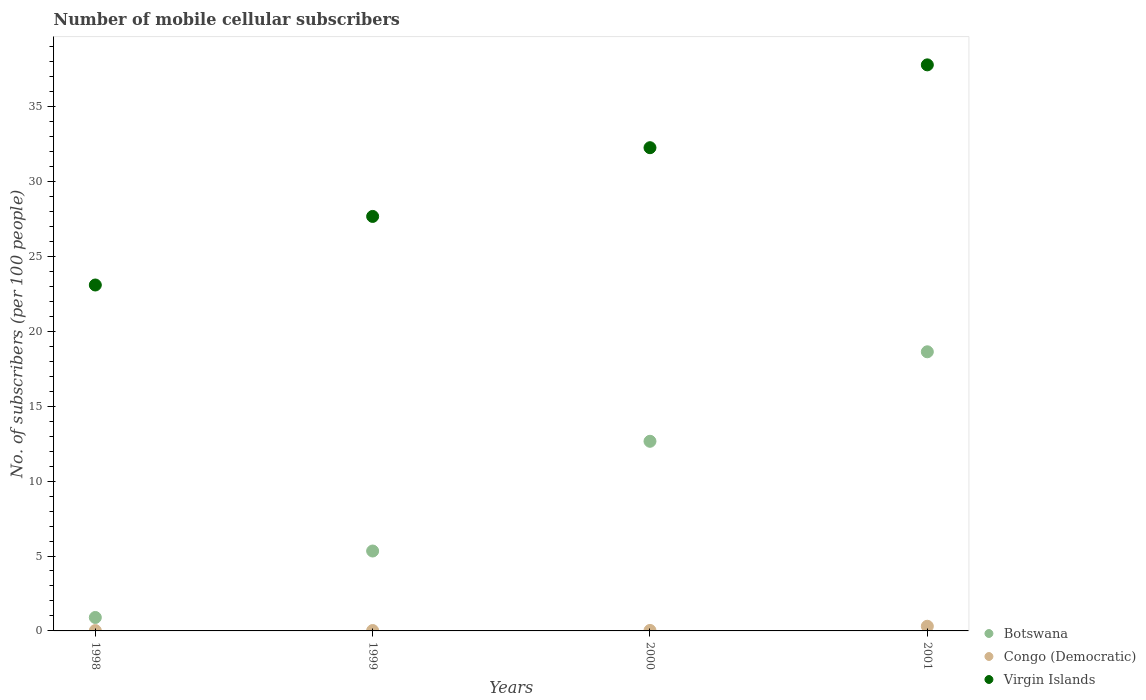Is the number of dotlines equal to the number of legend labels?
Your response must be concise. Yes. What is the number of mobile cellular subscribers in Virgin Islands in 2000?
Your answer should be compact. 32.25. Across all years, what is the maximum number of mobile cellular subscribers in Botswana?
Keep it short and to the point. 18.63. Across all years, what is the minimum number of mobile cellular subscribers in Botswana?
Your answer should be very brief. 0.9. In which year was the number of mobile cellular subscribers in Botswana maximum?
Give a very brief answer. 2001. What is the total number of mobile cellular subscribers in Virgin Islands in the graph?
Offer a very short reply. 120.8. What is the difference between the number of mobile cellular subscribers in Botswana in 1999 and that in 2001?
Keep it short and to the point. -13.3. What is the difference between the number of mobile cellular subscribers in Virgin Islands in 1998 and the number of mobile cellular subscribers in Congo (Democratic) in 1999?
Offer a terse response. 23.06. What is the average number of mobile cellular subscribers in Virgin Islands per year?
Your answer should be very brief. 30.2. In the year 2001, what is the difference between the number of mobile cellular subscribers in Virgin Islands and number of mobile cellular subscribers in Botswana?
Offer a terse response. 19.15. What is the ratio of the number of mobile cellular subscribers in Congo (Democratic) in 1999 to that in 2001?
Offer a very short reply. 0.08. Is the number of mobile cellular subscribers in Virgin Islands in 1999 less than that in 2000?
Your response must be concise. Yes. What is the difference between the highest and the second highest number of mobile cellular subscribers in Virgin Islands?
Your response must be concise. 5.53. What is the difference between the highest and the lowest number of mobile cellular subscribers in Virgin Islands?
Ensure brevity in your answer.  14.69. In how many years, is the number of mobile cellular subscribers in Congo (Democratic) greater than the average number of mobile cellular subscribers in Congo (Democratic) taken over all years?
Ensure brevity in your answer.  1. Is the sum of the number of mobile cellular subscribers in Botswana in 1998 and 2000 greater than the maximum number of mobile cellular subscribers in Congo (Democratic) across all years?
Ensure brevity in your answer.  Yes. Does the number of mobile cellular subscribers in Congo (Democratic) monotonically increase over the years?
Offer a terse response. Yes. Is the number of mobile cellular subscribers in Virgin Islands strictly greater than the number of mobile cellular subscribers in Congo (Democratic) over the years?
Offer a terse response. Yes. Is the number of mobile cellular subscribers in Botswana strictly less than the number of mobile cellular subscribers in Congo (Democratic) over the years?
Ensure brevity in your answer.  No. How many dotlines are there?
Your answer should be very brief. 3. Are the values on the major ticks of Y-axis written in scientific E-notation?
Your answer should be very brief. No. What is the title of the graph?
Offer a terse response. Number of mobile cellular subscribers. What is the label or title of the Y-axis?
Your response must be concise. No. of subscribers (per 100 people). What is the No. of subscribers (per 100 people) in Botswana in 1998?
Your response must be concise. 0.9. What is the No. of subscribers (per 100 people) of Congo (Democratic) in 1998?
Give a very brief answer. 0.02. What is the No. of subscribers (per 100 people) in Virgin Islands in 1998?
Offer a very short reply. 23.09. What is the No. of subscribers (per 100 people) of Botswana in 1999?
Ensure brevity in your answer.  5.33. What is the No. of subscribers (per 100 people) in Congo (Democratic) in 1999?
Provide a short and direct response. 0.03. What is the No. of subscribers (per 100 people) in Virgin Islands in 1999?
Give a very brief answer. 27.67. What is the No. of subscribers (per 100 people) in Botswana in 2000?
Give a very brief answer. 12.66. What is the No. of subscribers (per 100 people) of Congo (Democratic) in 2000?
Your answer should be very brief. 0.03. What is the No. of subscribers (per 100 people) of Virgin Islands in 2000?
Your answer should be compact. 32.25. What is the No. of subscribers (per 100 people) of Botswana in 2001?
Offer a terse response. 18.63. What is the No. of subscribers (per 100 people) of Congo (Democratic) in 2001?
Make the answer very short. 0.31. What is the No. of subscribers (per 100 people) of Virgin Islands in 2001?
Offer a terse response. 37.78. Across all years, what is the maximum No. of subscribers (per 100 people) of Botswana?
Provide a short and direct response. 18.63. Across all years, what is the maximum No. of subscribers (per 100 people) of Congo (Democratic)?
Provide a succinct answer. 0.31. Across all years, what is the maximum No. of subscribers (per 100 people) in Virgin Islands?
Your answer should be very brief. 37.78. Across all years, what is the minimum No. of subscribers (per 100 people) of Botswana?
Your response must be concise. 0.9. Across all years, what is the minimum No. of subscribers (per 100 people) of Congo (Democratic)?
Provide a short and direct response. 0.02. Across all years, what is the minimum No. of subscribers (per 100 people) in Virgin Islands?
Your answer should be very brief. 23.09. What is the total No. of subscribers (per 100 people) of Botswana in the graph?
Your answer should be compact. 37.52. What is the total No. of subscribers (per 100 people) of Congo (Democratic) in the graph?
Your answer should be very brief. 0.39. What is the total No. of subscribers (per 100 people) in Virgin Islands in the graph?
Provide a short and direct response. 120.8. What is the difference between the No. of subscribers (per 100 people) of Botswana in 1998 and that in 1999?
Your response must be concise. -4.44. What is the difference between the No. of subscribers (per 100 people) of Congo (Democratic) in 1998 and that in 1999?
Provide a short and direct response. -0. What is the difference between the No. of subscribers (per 100 people) in Virgin Islands in 1998 and that in 1999?
Ensure brevity in your answer.  -4.58. What is the difference between the No. of subscribers (per 100 people) in Botswana in 1998 and that in 2000?
Your answer should be compact. -11.76. What is the difference between the No. of subscribers (per 100 people) in Congo (Democratic) in 1998 and that in 2000?
Give a very brief answer. -0.01. What is the difference between the No. of subscribers (per 100 people) in Virgin Islands in 1998 and that in 2000?
Make the answer very short. -9.16. What is the difference between the No. of subscribers (per 100 people) in Botswana in 1998 and that in 2001?
Give a very brief answer. -17.73. What is the difference between the No. of subscribers (per 100 people) in Congo (Democratic) in 1998 and that in 2001?
Offer a very short reply. -0.29. What is the difference between the No. of subscribers (per 100 people) of Virgin Islands in 1998 and that in 2001?
Your response must be concise. -14.69. What is the difference between the No. of subscribers (per 100 people) in Botswana in 1999 and that in 2000?
Your answer should be very brief. -7.32. What is the difference between the No. of subscribers (per 100 people) in Congo (Democratic) in 1999 and that in 2000?
Keep it short and to the point. -0.01. What is the difference between the No. of subscribers (per 100 people) in Virgin Islands in 1999 and that in 2000?
Provide a succinct answer. -4.59. What is the difference between the No. of subscribers (per 100 people) in Botswana in 1999 and that in 2001?
Provide a short and direct response. -13.3. What is the difference between the No. of subscribers (per 100 people) of Congo (Democratic) in 1999 and that in 2001?
Provide a short and direct response. -0.29. What is the difference between the No. of subscribers (per 100 people) in Virgin Islands in 1999 and that in 2001?
Make the answer very short. -10.12. What is the difference between the No. of subscribers (per 100 people) of Botswana in 2000 and that in 2001?
Keep it short and to the point. -5.97. What is the difference between the No. of subscribers (per 100 people) of Congo (Democratic) in 2000 and that in 2001?
Your answer should be compact. -0.28. What is the difference between the No. of subscribers (per 100 people) of Virgin Islands in 2000 and that in 2001?
Ensure brevity in your answer.  -5.53. What is the difference between the No. of subscribers (per 100 people) in Botswana in 1998 and the No. of subscribers (per 100 people) in Congo (Democratic) in 1999?
Offer a very short reply. 0.87. What is the difference between the No. of subscribers (per 100 people) in Botswana in 1998 and the No. of subscribers (per 100 people) in Virgin Islands in 1999?
Ensure brevity in your answer.  -26.77. What is the difference between the No. of subscribers (per 100 people) of Congo (Democratic) in 1998 and the No. of subscribers (per 100 people) of Virgin Islands in 1999?
Your answer should be very brief. -27.65. What is the difference between the No. of subscribers (per 100 people) of Botswana in 1998 and the No. of subscribers (per 100 people) of Congo (Democratic) in 2000?
Provide a succinct answer. 0.87. What is the difference between the No. of subscribers (per 100 people) of Botswana in 1998 and the No. of subscribers (per 100 people) of Virgin Islands in 2000?
Make the answer very short. -31.36. What is the difference between the No. of subscribers (per 100 people) of Congo (Democratic) in 1998 and the No. of subscribers (per 100 people) of Virgin Islands in 2000?
Your response must be concise. -32.23. What is the difference between the No. of subscribers (per 100 people) in Botswana in 1998 and the No. of subscribers (per 100 people) in Congo (Democratic) in 2001?
Your answer should be very brief. 0.59. What is the difference between the No. of subscribers (per 100 people) of Botswana in 1998 and the No. of subscribers (per 100 people) of Virgin Islands in 2001?
Ensure brevity in your answer.  -36.89. What is the difference between the No. of subscribers (per 100 people) of Congo (Democratic) in 1998 and the No. of subscribers (per 100 people) of Virgin Islands in 2001?
Offer a very short reply. -37.76. What is the difference between the No. of subscribers (per 100 people) of Botswana in 1999 and the No. of subscribers (per 100 people) of Congo (Democratic) in 2000?
Make the answer very short. 5.3. What is the difference between the No. of subscribers (per 100 people) in Botswana in 1999 and the No. of subscribers (per 100 people) in Virgin Islands in 2000?
Provide a short and direct response. -26.92. What is the difference between the No. of subscribers (per 100 people) in Congo (Democratic) in 1999 and the No. of subscribers (per 100 people) in Virgin Islands in 2000?
Make the answer very short. -32.23. What is the difference between the No. of subscribers (per 100 people) of Botswana in 1999 and the No. of subscribers (per 100 people) of Congo (Democratic) in 2001?
Offer a terse response. 5.02. What is the difference between the No. of subscribers (per 100 people) in Botswana in 1999 and the No. of subscribers (per 100 people) in Virgin Islands in 2001?
Offer a very short reply. -32.45. What is the difference between the No. of subscribers (per 100 people) of Congo (Democratic) in 1999 and the No. of subscribers (per 100 people) of Virgin Islands in 2001?
Ensure brevity in your answer.  -37.76. What is the difference between the No. of subscribers (per 100 people) in Botswana in 2000 and the No. of subscribers (per 100 people) in Congo (Democratic) in 2001?
Offer a very short reply. 12.35. What is the difference between the No. of subscribers (per 100 people) in Botswana in 2000 and the No. of subscribers (per 100 people) in Virgin Islands in 2001?
Your response must be concise. -25.13. What is the difference between the No. of subscribers (per 100 people) in Congo (Democratic) in 2000 and the No. of subscribers (per 100 people) in Virgin Islands in 2001?
Offer a very short reply. -37.75. What is the average No. of subscribers (per 100 people) in Botswana per year?
Make the answer very short. 9.38. What is the average No. of subscribers (per 100 people) of Congo (Democratic) per year?
Make the answer very short. 0.1. What is the average No. of subscribers (per 100 people) of Virgin Islands per year?
Offer a very short reply. 30.2. In the year 1998, what is the difference between the No. of subscribers (per 100 people) of Botswana and No. of subscribers (per 100 people) of Congo (Democratic)?
Ensure brevity in your answer.  0.88. In the year 1998, what is the difference between the No. of subscribers (per 100 people) of Botswana and No. of subscribers (per 100 people) of Virgin Islands?
Provide a succinct answer. -22.19. In the year 1998, what is the difference between the No. of subscribers (per 100 people) in Congo (Democratic) and No. of subscribers (per 100 people) in Virgin Islands?
Provide a succinct answer. -23.07. In the year 1999, what is the difference between the No. of subscribers (per 100 people) in Botswana and No. of subscribers (per 100 people) in Congo (Democratic)?
Offer a very short reply. 5.31. In the year 1999, what is the difference between the No. of subscribers (per 100 people) in Botswana and No. of subscribers (per 100 people) in Virgin Islands?
Make the answer very short. -22.33. In the year 1999, what is the difference between the No. of subscribers (per 100 people) of Congo (Democratic) and No. of subscribers (per 100 people) of Virgin Islands?
Offer a very short reply. -27.64. In the year 2000, what is the difference between the No. of subscribers (per 100 people) of Botswana and No. of subscribers (per 100 people) of Congo (Democratic)?
Your response must be concise. 12.63. In the year 2000, what is the difference between the No. of subscribers (per 100 people) in Botswana and No. of subscribers (per 100 people) in Virgin Islands?
Your answer should be very brief. -19.6. In the year 2000, what is the difference between the No. of subscribers (per 100 people) of Congo (Democratic) and No. of subscribers (per 100 people) of Virgin Islands?
Give a very brief answer. -32.22. In the year 2001, what is the difference between the No. of subscribers (per 100 people) in Botswana and No. of subscribers (per 100 people) in Congo (Democratic)?
Keep it short and to the point. 18.32. In the year 2001, what is the difference between the No. of subscribers (per 100 people) of Botswana and No. of subscribers (per 100 people) of Virgin Islands?
Your response must be concise. -19.15. In the year 2001, what is the difference between the No. of subscribers (per 100 people) of Congo (Democratic) and No. of subscribers (per 100 people) of Virgin Islands?
Ensure brevity in your answer.  -37.47. What is the ratio of the No. of subscribers (per 100 people) of Botswana in 1998 to that in 1999?
Offer a very short reply. 0.17. What is the ratio of the No. of subscribers (per 100 people) of Congo (Democratic) in 1998 to that in 1999?
Offer a terse response. 0.85. What is the ratio of the No. of subscribers (per 100 people) in Virgin Islands in 1998 to that in 1999?
Provide a short and direct response. 0.83. What is the ratio of the No. of subscribers (per 100 people) of Botswana in 1998 to that in 2000?
Make the answer very short. 0.07. What is the ratio of the No. of subscribers (per 100 people) in Congo (Democratic) in 1998 to that in 2000?
Keep it short and to the point. 0.7. What is the ratio of the No. of subscribers (per 100 people) of Virgin Islands in 1998 to that in 2000?
Make the answer very short. 0.72. What is the ratio of the No. of subscribers (per 100 people) of Botswana in 1998 to that in 2001?
Ensure brevity in your answer.  0.05. What is the ratio of the No. of subscribers (per 100 people) of Congo (Democratic) in 1998 to that in 2001?
Make the answer very short. 0.07. What is the ratio of the No. of subscribers (per 100 people) in Virgin Islands in 1998 to that in 2001?
Offer a very short reply. 0.61. What is the ratio of the No. of subscribers (per 100 people) in Botswana in 1999 to that in 2000?
Your response must be concise. 0.42. What is the ratio of the No. of subscribers (per 100 people) in Congo (Democratic) in 1999 to that in 2000?
Your response must be concise. 0.82. What is the ratio of the No. of subscribers (per 100 people) of Virgin Islands in 1999 to that in 2000?
Make the answer very short. 0.86. What is the ratio of the No. of subscribers (per 100 people) in Botswana in 1999 to that in 2001?
Provide a short and direct response. 0.29. What is the ratio of the No. of subscribers (per 100 people) in Congo (Democratic) in 1999 to that in 2001?
Offer a very short reply. 0.08. What is the ratio of the No. of subscribers (per 100 people) of Virgin Islands in 1999 to that in 2001?
Make the answer very short. 0.73. What is the ratio of the No. of subscribers (per 100 people) in Botswana in 2000 to that in 2001?
Provide a succinct answer. 0.68. What is the ratio of the No. of subscribers (per 100 people) in Congo (Democratic) in 2000 to that in 2001?
Ensure brevity in your answer.  0.1. What is the ratio of the No. of subscribers (per 100 people) in Virgin Islands in 2000 to that in 2001?
Your answer should be compact. 0.85. What is the difference between the highest and the second highest No. of subscribers (per 100 people) in Botswana?
Offer a terse response. 5.97. What is the difference between the highest and the second highest No. of subscribers (per 100 people) of Congo (Democratic)?
Your answer should be compact. 0.28. What is the difference between the highest and the second highest No. of subscribers (per 100 people) of Virgin Islands?
Your answer should be very brief. 5.53. What is the difference between the highest and the lowest No. of subscribers (per 100 people) of Botswana?
Keep it short and to the point. 17.73. What is the difference between the highest and the lowest No. of subscribers (per 100 people) in Congo (Democratic)?
Provide a succinct answer. 0.29. What is the difference between the highest and the lowest No. of subscribers (per 100 people) of Virgin Islands?
Your answer should be compact. 14.69. 